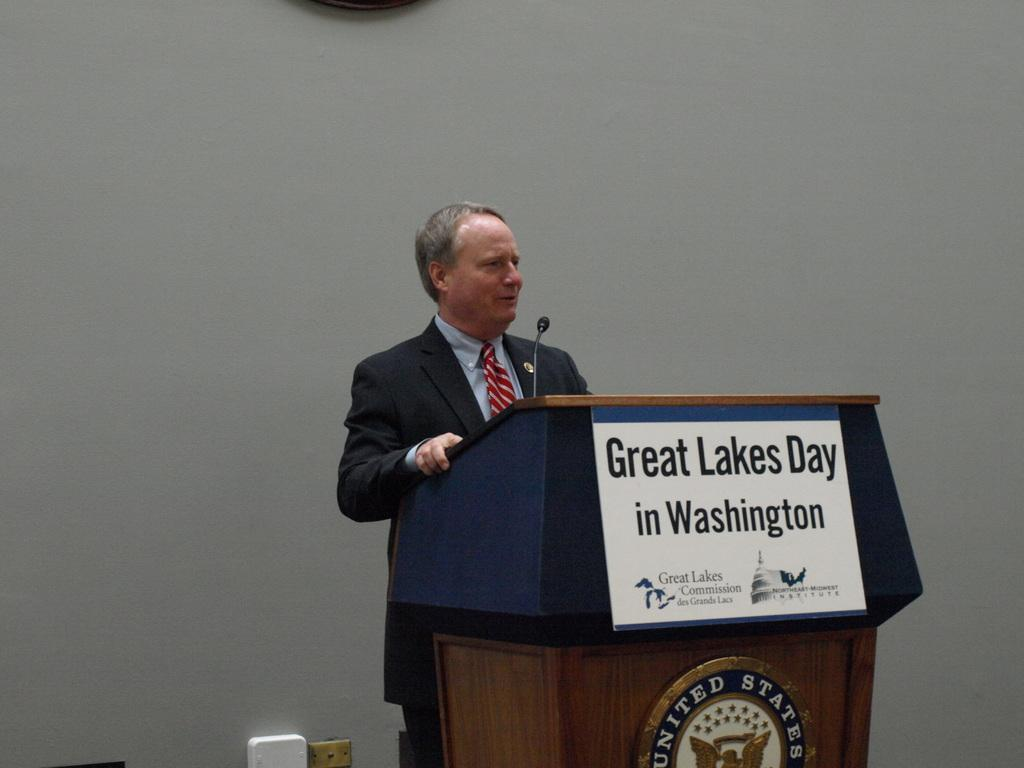<image>
Relay a brief, clear account of the picture shown. Man giving a speech in front of a podium that says "Great Lakes Day". 